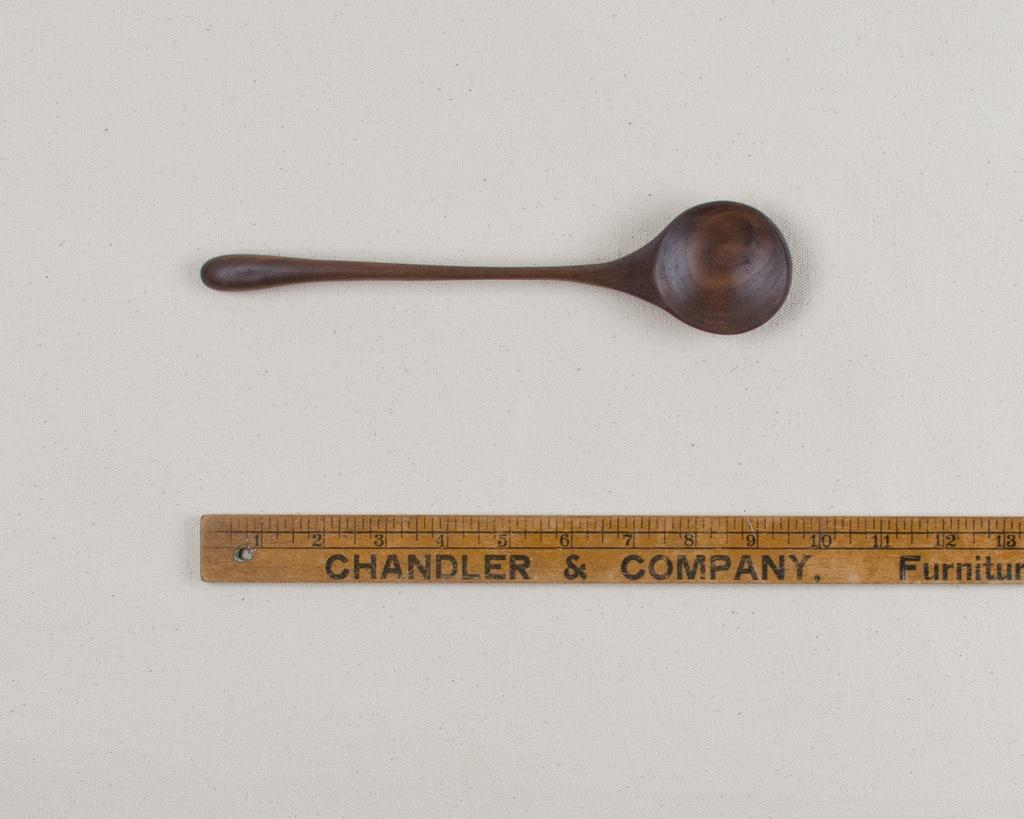<image>
Provide a brief description of the given image. A wooden spoon next to a Chandler and company ruler 